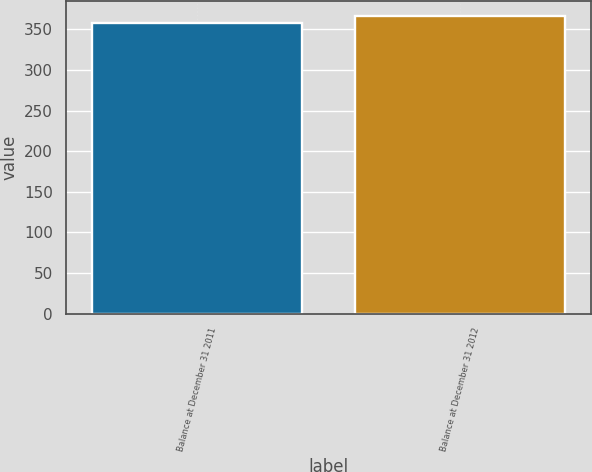Convert chart. <chart><loc_0><loc_0><loc_500><loc_500><bar_chart><fcel>Balance at December 31 2011<fcel>Balance at December 31 2012<nl><fcel>358<fcel>367<nl></chart> 